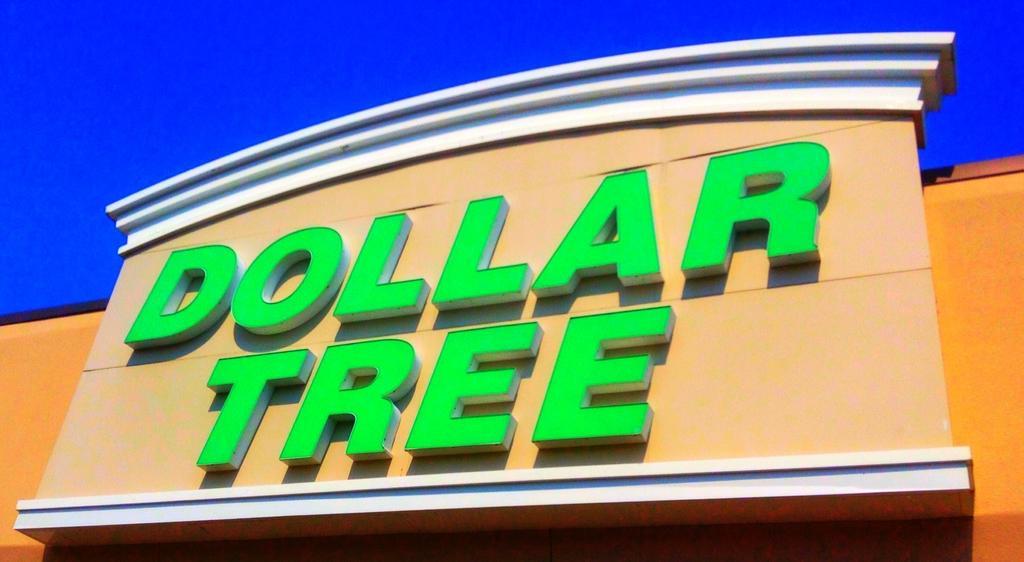Can you describe this image briefly? In this image there is a building. On it dollar tree is written. 